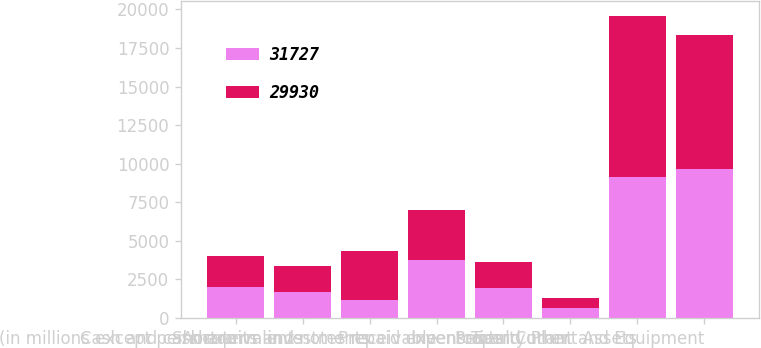<chart> <loc_0><loc_0><loc_500><loc_500><stacked_bar_chart><ecel><fcel>(in millions except per share<fcel>Cash and cash equivalents<fcel>Short-term investments<fcel>Accounts and notes receivable<fcel>Inventories<fcel>Prepaid expenses and other<fcel>Total Current Assets<fcel>Property Plant and Equipment<nl><fcel>31727<fcel>2006<fcel>1651<fcel>1171<fcel>3725<fcel>1926<fcel>657<fcel>9130<fcel>9687<nl><fcel>29930<fcel>2005<fcel>1716<fcel>3166<fcel>3261<fcel>1693<fcel>618<fcel>10454<fcel>8681<nl></chart> 